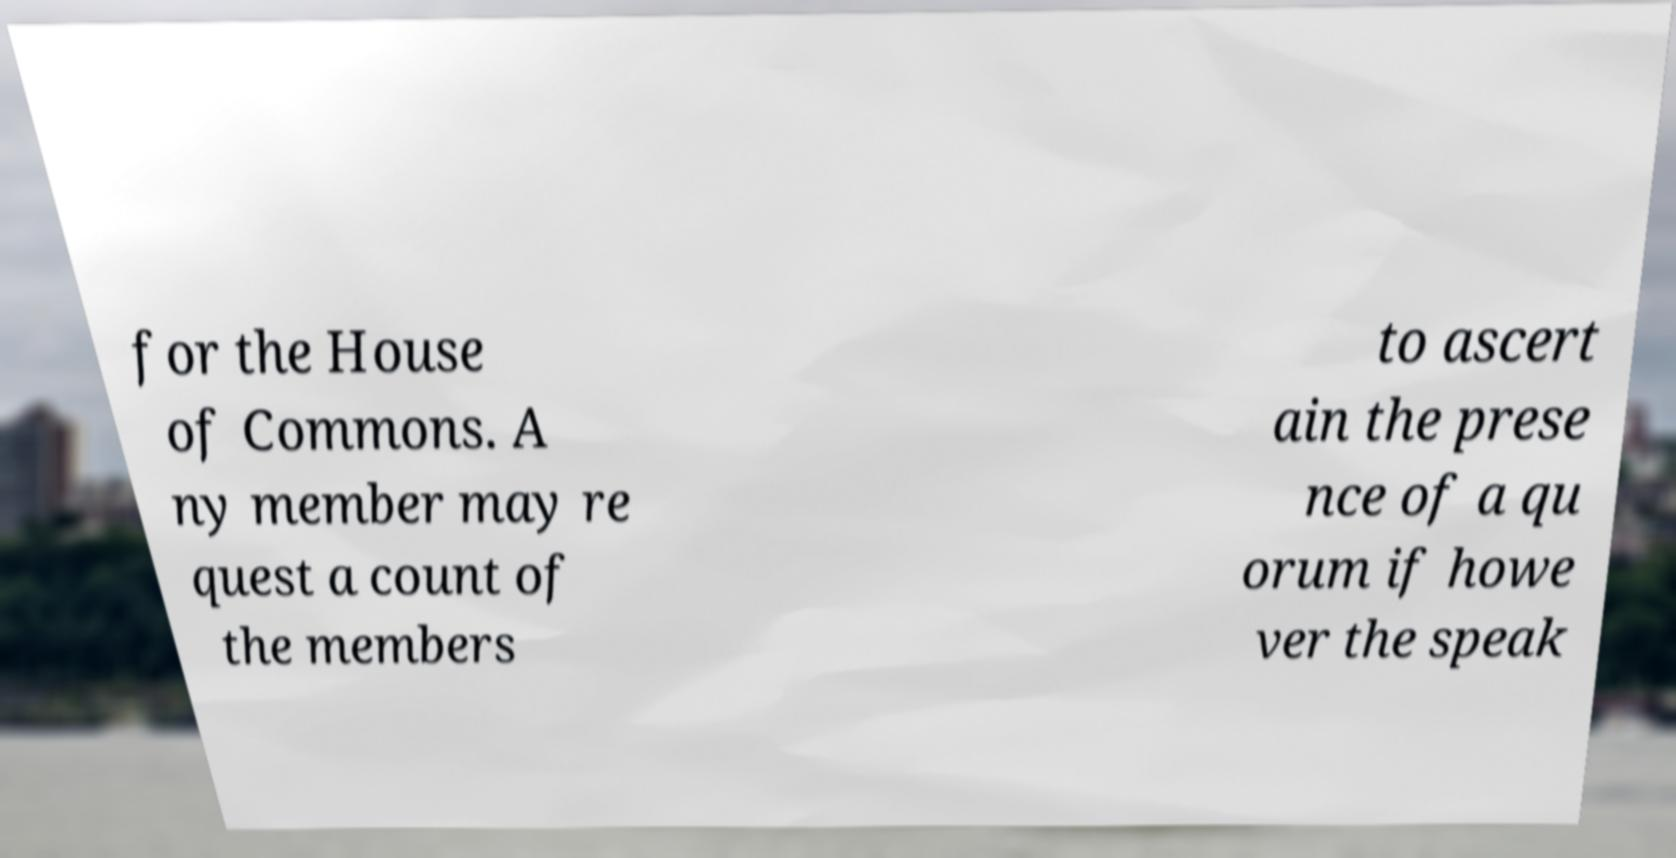What messages or text are displayed in this image? I need them in a readable, typed format. for the House of Commons. A ny member may re quest a count of the members to ascert ain the prese nce of a qu orum if howe ver the speak 